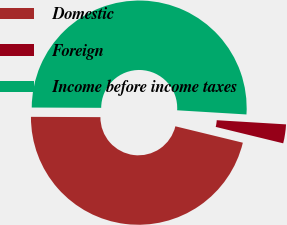Convert chart. <chart><loc_0><loc_0><loc_500><loc_500><pie_chart><fcel>Domestic<fcel>Foreign<fcel>Income before income taxes<nl><fcel>46.27%<fcel>2.84%<fcel>50.89%<nl></chart> 